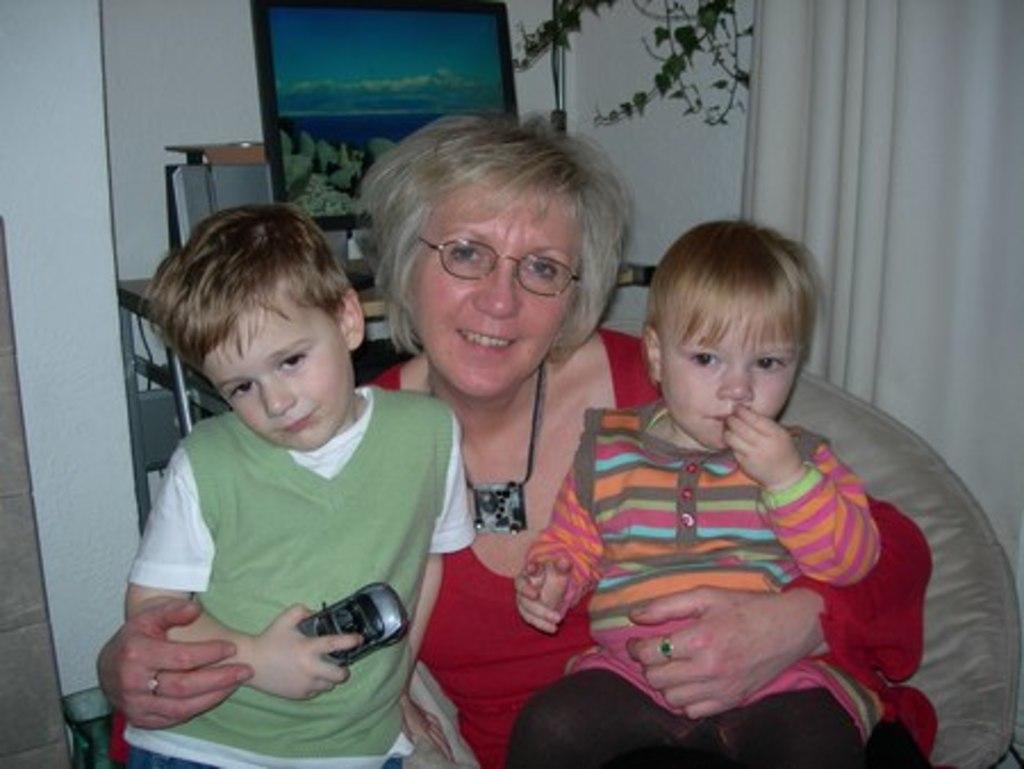Can you describe this image briefly? In this image I can see a woman wearing red color dress is sitting on a couch and holding two children. In the background I can see the wall, the curtain, a plant and a desk and on the desk I can see a monitor. 